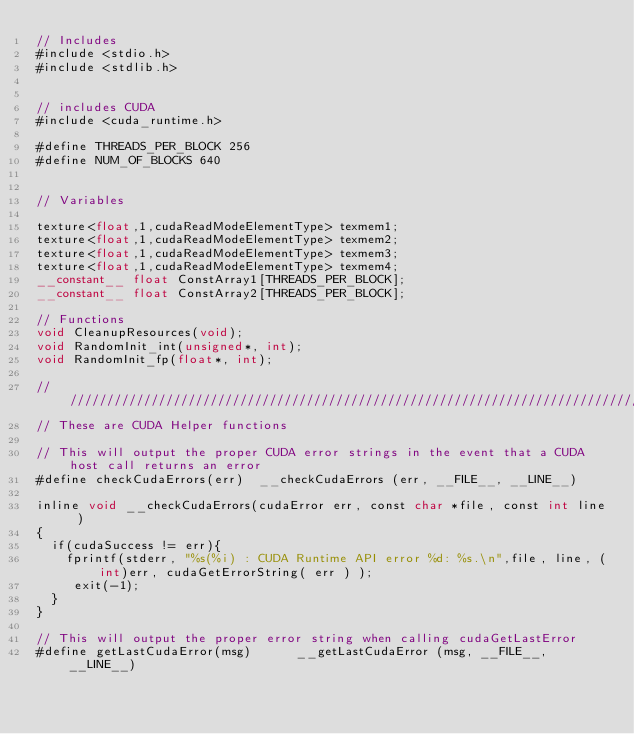Convert code to text. <code><loc_0><loc_0><loc_500><loc_500><_Cuda_>// Includes
#include <stdio.h>
#include <stdlib.h>


// includes CUDA
#include <cuda_runtime.h>

#define THREADS_PER_BLOCK 256
#define NUM_OF_BLOCKS 640


// Variables

texture<float,1,cudaReadModeElementType> texmem1;
texture<float,1,cudaReadModeElementType> texmem2;
texture<float,1,cudaReadModeElementType> texmem3;
texture<float,1,cudaReadModeElementType> texmem4;
__constant__ float ConstArray1[THREADS_PER_BLOCK];
__constant__ float ConstArray2[THREADS_PER_BLOCK];

// Functions
void CleanupResources(void);
void RandomInit_int(unsigned*, int);
void RandomInit_fp(float*, int);

////////////////////////////////////////////////////////////////////////////////
// These are CUDA Helper functions

// This will output the proper CUDA error strings in the event that a CUDA host call returns an error
#define checkCudaErrors(err)  __checkCudaErrors (err, __FILE__, __LINE__)

inline void __checkCudaErrors(cudaError err, const char *file, const int line )
{
  if(cudaSuccess != err){
	fprintf(stderr, "%s(%i) : CUDA Runtime API error %d: %s.\n",file, line, (int)err, cudaGetErrorString( err ) );
	 exit(-1);
  }
}

// This will output the proper error string when calling cudaGetLastError
#define getLastCudaError(msg)      __getLastCudaError (msg, __FILE__, __LINE__)
</code> 